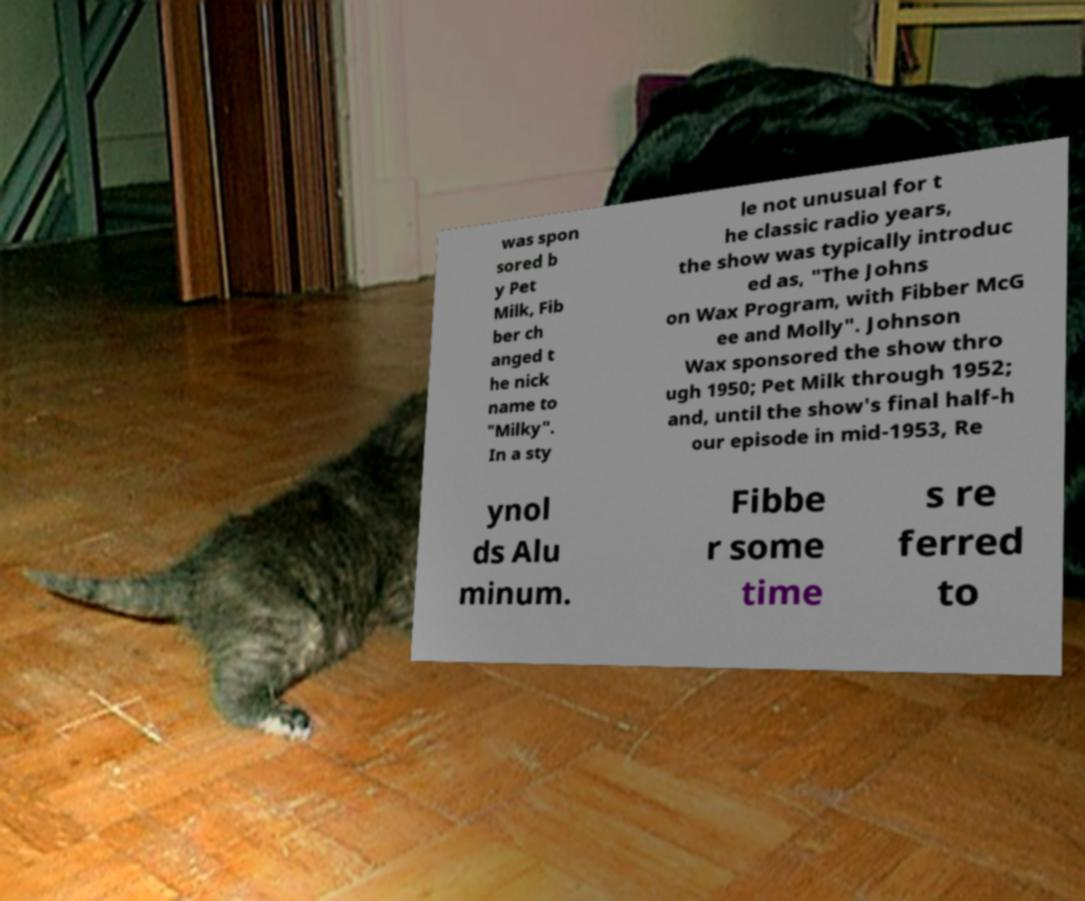Could you extract and type out the text from this image? was spon sored b y Pet Milk, Fib ber ch anged t he nick name to "Milky". In a sty le not unusual for t he classic radio years, the show was typically introduc ed as, "The Johns on Wax Program, with Fibber McG ee and Molly". Johnson Wax sponsored the show thro ugh 1950; Pet Milk through 1952; and, until the show's final half-h our episode in mid-1953, Re ynol ds Alu minum. Fibbe r some time s re ferred to 